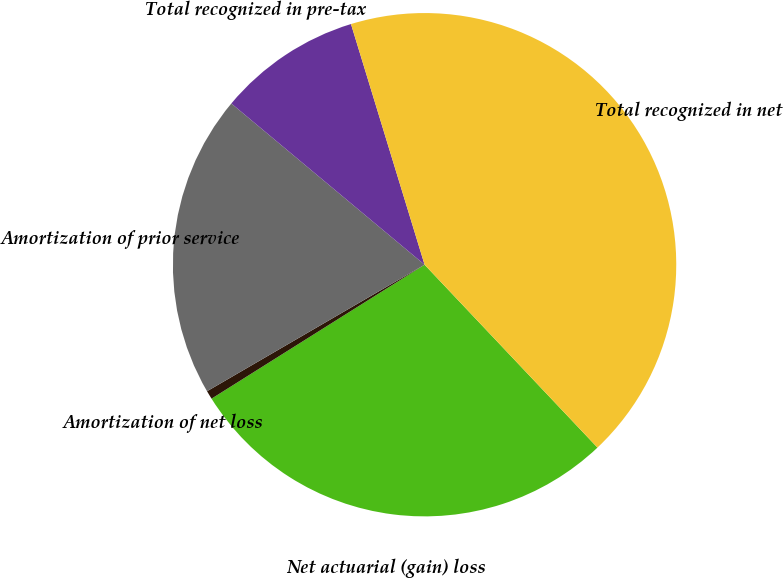Convert chart to OTSL. <chart><loc_0><loc_0><loc_500><loc_500><pie_chart><fcel>Net actuarial (gain) loss<fcel>Amortization of net loss<fcel>Amortization of prior service<fcel>Total recognized in pre-tax<fcel>Total recognized in net<nl><fcel>28.12%<fcel>0.55%<fcel>19.45%<fcel>9.21%<fcel>42.67%<nl></chart> 